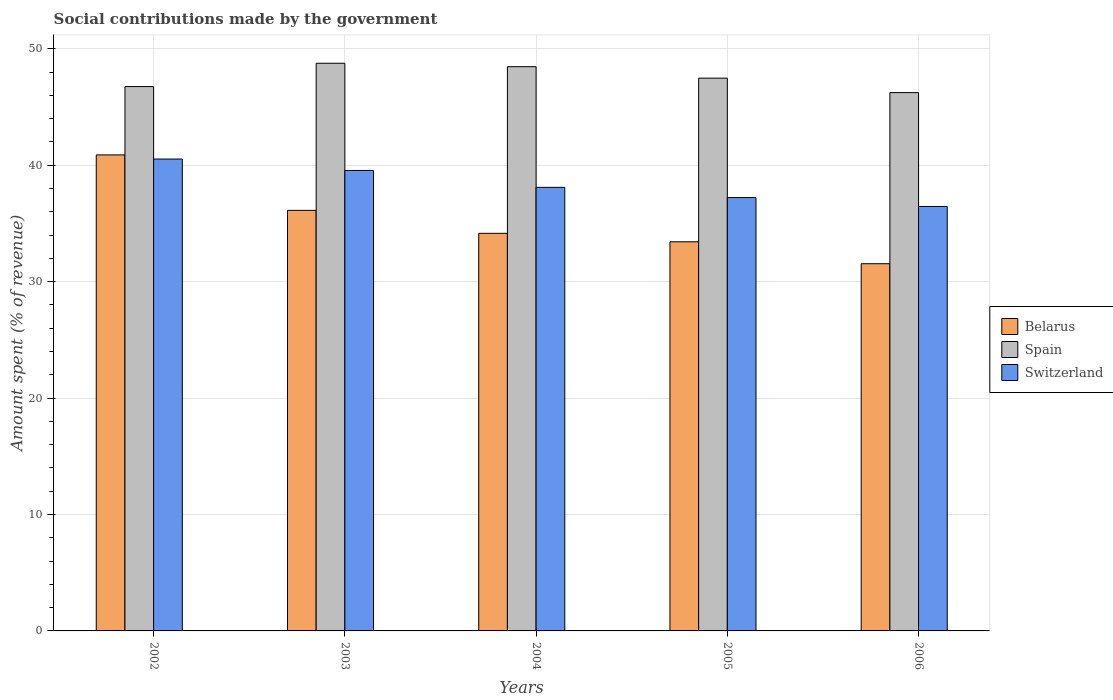Are the number of bars on each tick of the X-axis equal?
Offer a terse response. Yes. How many bars are there on the 3rd tick from the left?
Ensure brevity in your answer.  3. How many bars are there on the 5th tick from the right?
Offer a terse response. 3. In how many cases, is the number of bars for a given year not equal to the number of legend labels?
Your response must be concise. 0. What is the amount spent (in %) on social contributions in Belarus in 2006?
Provide a short and direct response. 31.54. Across all years, what is the maximum amount spent (in %) on social contributions in Switzerland?
Offer a terse response. 40.53. Across all years, what is the minimum amount spent (in %) on social contributions in Switzerland?
Your answer should be compact. 36.46. In which year was the amount spent (in %) on social contributions in Belarus maximum?
Keep it short and to the point. 2002. In which year was the amount spent (in %) on social contributions in Belarus minimum?
Keep it short and to the point. 2006. What is the total amount spent (in %) on social contributions in Belarus in the graph?
Offer a very short reply. 176.11. What is the difference between the amount spent (in %) on social contributions in Spain in 2003 and that in 2006?
Offer a terse response. 2.52. What is the difference between the amount spent (in %) on social contributions in Spain in 2006 and the amount spent (in %) on social contributions in Switzerland in 2002?
Offer a very short reply. 5.71. What is the average amount spent (in %) on social contributions in Spain per year?
Provide a succinct answer. 47.54. In the year 2003, what is the difference between the amount spent (in %) on social contributions in Belarus and amount spent (in %) on social contributions in Spain?
Your answer should be very brief. -12.63. What is the ratio of the amount spent (in %) on social contributions in Spain in 2002 to that in 2006?
Your answer should be very brief. 1.01. Is the difference between the amount spent (in %) on social contributions in Belarus in 2003 and 2004 greater than the difference between the amount spent (in %) on social contributions in Spain in 2003 and 2004?
Make the answer very short. Yes. What is the difference between the highest and the second highest amount spent (in %) on social contributions in Belarus?
Provide a succinct answer. 4.76. What is the difference between the highest and the lowest amount spent (in %) on social contributions in Belarus?
Your response must be concise. 9.34. Is the sum of the amount spent (in %) on social contributions in Switzerland in 2003 and 2006 greater than the maximum amount spent (in %) on social contributions in Spain across all years?
Your response must be concise. Yes. What does the 2nd bar from the left in 2003 represents?
Make the answer very short. Spain. Is it the case that in every year, the sum of the amount spent (in %) on social contributions in Spain and amount spent (in %) on social contributions in Belarus is greater than the amount spent (in %) on social contributions in Switzerland?
Provide a succinct answer. Yes. What is the difference between two consecutive major ticks on the Y-axis?
Your response must be concise. 10. Are the values on the major ticks of Y-axis written in scientific E-notation?
Your answer should be compact. No. Does the graph contain any zero values?
Offer a terse response. No. Does the graph contain grids?
Provide a succinct answer. Yes. Where does the legend appear in the graph?
Offer a terse response. Center right. How many legend labels are there?
Make the answer very short. 3. How are the legend labels stacked?
Offer a terse response. Vertical. What is the title of the graph?
Keep it short and to the point. Social contributions made by the government. Does "Spain" appear as one of the legend labels in the graph?
Keep it short and to the point. Yes. What is the label or title of the X-axis?
Provide a short and direct response. Years. What is the label or title of the Y-axis?
Give a very brief answer. Amount spent (% of revenue). What is the Amount spent (% of revenue) of Belarus in 2002?
Your answer should be very brief. 40.88. What is the Amount spent (% of revenue) in Spain in 2002?
Offer a terse response. 46.75. What is the Amount spent (% of revenue) in Switzerland in 2002?
Your answer should be very brief. 40.53. What is the Amount spent (% of revenue) of Belarus in 2003?
Your answer should be very brief. 36.12. What is the Amount spent (% of revenue) of Spain in 2003?
Give a very brief answer. 48.75. What is the Amount spent (% of revenue) in Switzerland in 2003?
Make the answer very short. 39.55. What is the Amount spent (% of revenue) in Belarus in 2004?
Ensure brevity in your answer.  34.15. What is the Amount spent (% of revenue) in Spain in 2004?
Ensure brevity in your answer.  48.46. What is the Amount spent (% of revenue) of Switzerland in 2004?
Give a very brief answer. 38.1. What is the Amount spent (% of revenue) in Belarus in 2005?
Offer a very short reply. 33.42. What is the Amount spent (% of revenue) of Spain in 2005?
Offer a terse response. 47.48. What is the Amount spent (% of revenue) of Switzerland in 2005?
Offer a terse response. 37.22. What is the Amount spent (% of revenue) in Belarus in 2006?
Provide a short and direct response. 31.54. What is the Amount spent (% of revenue) of Spain in 2006?
Your answer should be very brief. 46.23. What is the Amount spent (% of revenue) in Switzerland in 2006?
Provide a short and direct response. 36.46. Across all years, what is the maximum Amount spent (% of revenue) of Belarus?
Give a very brief answer. 40.88. Across all years, what is the maximum Amount spent (% of revenue) of Spain?
Offer a very short reply. 48.75. Across all years, what is the maximum Amount spent (% of revenue) in Switzerland?
Your answer should be very brief. 40.53. Across all years, what is the minimum Amount spent (% of revenue) in Belarus?
Provide a succinct answer. 31.54. Across all years, what is the minimum Amount spent (% of revenue) of Spain?
Give a very brief answer. 46.23. Across all years, what is the minimum Amount spent (% of revenue) of Switzerland?
Your answer should be compact. 36.46. What is the total Amount spent (% of revenue) of Belarus in the graph?
Keep it short and to the point. 176.11. What is the total Amount spent (% of revenue) in Spain in the graph?
Offer a terse response. 237.68. What is the total Amount spent (% of revenue) in Switzerland in the graph?
Offer a terse response. 191.85. What is the difference between the Amount spent (% of revenue) of Belarus in 2002 and that in 2003?
Offer a terse response. 4.76. What is the difference between the Amount spent (% of revenue) of Spain in 2002 and that in 2003?
Give a very brief answer. -2. What is the difference between the Amount spent (% of revenue) of Switzerland in 2002 and that in 2003?
Make the answer very short. 0.98. What is the difference between the Amount spent (% of revenue) of Belarus in 2002 and that in 2004?
Offer a terse response. 6.74. What is the difference between the Amount spent (% of revenue) in Spain in 2002 and that in 2004?
Give a very brief answer. -1.71. What is the difference between the Amount spent (% of revenue) of Switzerland in 2002 and that in 2004?
Keep it short and to the point. 2.43. What is the difference between the Amount spent (% of revenue) in Belarus in 2002 and that in 2005?
Offer a very short reply. 7.46. What is the difference between the Amount spent (% of revenue) in Spain in 2002 and that in 2005?
Offer a terse response. -0.72. What is the difference between the Amount spent (% of revenue) of Switzerland in 2002 and that in 2005?
Keep it short and to the point. 3.31. What is the difference between the Amount spent (% of revenue) of Belarus in 2002 and that in 2006?
Ensure brevity in your answer.  9.34. What is the difference between the Amount spent (% of revenue) in Spain in 2002 and that in 2006?
Give a very brief answer. 0.52. What is the difference between the Amount spent (% of revenue) of Switzerland in 2002 and that in 2006?
Offer a very short reply. 4.07. What is the difference between the Amount spent (% of revenue) of Belarus in 2003 and that in 2004?
Provide a short and direct response. 1.97. What is the difference between the Amount spent (% of revenue) in Spain in 2003 and that in 2004?
Provide a succinct answer. 0.29. What is the difference between the Amount spent (% of revenue) of Switzerland in 2003 and that in 2004?
Your answer should be compact. 1.45. What is the difference between the Amount spent (% of revenue) in Belarus in 2003 and that in 2005?
Your response must be concise. 2.7. What is the difference between the Amount spent (% of revenue) of Spain in 2003 and that in 2005?
Make the answer very short. 1.28. What is the difference between the Amount spent (% of revenue) in Switzerland in 2003 and that in 2005?
Offer a terse response. 2.33. What is the difference between the Amount spent (% of revenue) of Belarus in 2003 and that in 2006?
Provide a short and direct response. 4.58. What is the difference between the Amount spent (% of revenue) in Spain in 2003 and that in 2006?
Offer a terse response. 2.52. What is the difference between the Amount spent (% of revenue) of Switzerland in 2003 and that in 2006?
Keep it short and to the point. 3.09. What is the difference between the Amount spent (% of revenue) of Belarus in 2004 and that in 2005?
Keep it short and to the point. 0.73. What is the difference between the Amount spent (% of revenue) in Spain in 2004 and that in 2005?
Give a very brief answer. 0.99. What is the difference between the Amount spent (% of revenue) in Switzerland in 2004 and that in 2005?
Your answer should be very brief. 0.88. What is the difference between the Amount spent (% of revenue) of Belarus in 2004 and that in 2006?
Offer a very short reply. 2.61. What is the difference between the Amount spent (% of revenue) in Spain in 2004 and that in 2006?
Make the answer very short. 2.23. What is the difference between the Amount spent (% of revenue) of Switzerland in 2004 and that in 2006?
Your answer should be compact. 1.64. What is the difference between the Amount spent (% of revenue) of Belarus in 2005 and that in 2006?
Give a very brief answer. 1.88. What is the difference between the Amount spent (% of revenue) of Spain in 2005 and that in 2006?
Your answer should be very brief. 1.24. What is the difference between the Amount spent (% of revenue) of Switzerland in 2005 and that in 2006?
Offer a very short reply. 0.76. What is the difference between the Amount spent (% of revenue) in Belarus in 2002 and the Amount spent (% of revenue) in Spain in 2003?
Provide a short and direct response. -7.87. What is the difference between the Amount spent (% of revenue) of Belarus in 2002 and the Amount spent (% of revenue) of Switzerland in 2003?
Ensure brevity in your answer.  1.34. What is the difference between the Amount spent (% of revenue) in Spain in 2002 and the Amount spent (% of revenue) in Switzerland in 2003?
Make the answer very short. 7.21. What is the difference between the Amount spent (% of revenue) in Belarus in 2002 and the Amount spent (% of revenue) in Spain in 2004?
Ensure brevity in your answer.  -7.58. What is the difference between the Amount spent (% of revenue) of Belarus in 2002 and the Amount spent (% of revenue) of Switzerland in 2004?
Provide a succinct answer. 2.79. What is the difference between the Amount spent (% of revenue) of Spain in 2002 and the Amount spent (% of revenue) of Switzerland in 2004?
Keep it short and to the point. 8.66. What is the difference between the Amount spent (% of revenue) in Belarus in 2002 and the Amount spent (% of revenue) in Spain in 2005?
Offer a terse response. -6.59. What is the difference between the Amount spent (% of revenue) in Belarus in 2002 and the Amount spent (% of revenue) in Switzerland in 2005?
Give a very brief answer. 3.66. What is the difference between the Amount spent (% of revenue) in Spain in 2002 and the Amount spent (% of revenue) in Switzerland in 2005?
Ensure brevity in your answer.  9.53. What is the difference between the Amount spent (% of revenue) of Belarus in 2002 and the Amount spent (% of revenue) of Spain in 2006?
Offer a very short reply. -5.35. What is the difference between the Amount spent (% of revenue) of Belarus in 2002 and the Amount spent (% of revenue) of Switzerland in 2006?
Your answer should be compact. 4.43. What is the difference between the Amount spent (% of revenue) in Spain in 2002 and the Amount spent (% of revenue) in Switzerland in 2006?
Provide a succinct answer. 10.3. What is the difference between the Amount spent (% of revenue) of Belarus in 2003 and the Amount spent (% of revenue) of Spain in 2004?
Your answer should be compact. -12.34. What is the difference between the Amount spent (% of revenue) in Belarus in 2003 and the Amount spent (% of revenue) in Switzerland in 2004?
Your response must be concise. -1.98. What is the difference between the Amount spent (% of revenue) of Spain in 2003 and the Amount spent (% of revenue) of Switzerland in 2004?
Your answer should be very brief. 10.66. What is the difference between the Amount spent (% of revenue) of Belarus in 2003 and the Amount spent (% of revenue) of Spain in 2005?
Keep it short and to the point. -11.35. What is the difference between the Amount spent (% of revenue) in Belarus in 2003 and the Amount spent (% of revenue) in Switzerland in 2005?
Provide a short and direct response. -1.1. What is the difference between the Amount spent (% of revenue) in Spain in 2003 and the Amount spent (% of revenue) in Switzerland in 2005?
Offer a terse response. 11.54. What is the difference between the Amount spent (% of revenue) of Belarus in 2003 and the Amount spent (% of revenue) of Spain in 2006?
Ensure brevity in your answer.  -10.11. What is the difference between the Amount spent (% of revenue) in Belarus in 2003 and the Amount spent (% of revenue) in Switzerland in 2006?
Keep it short and to the point. -0.33. What is the difference between the Amount spent (% of revenue) in Spain in 2003 and the Amount spent (% of revenue) in Switzerland in 2006?
Provide a short and direct response. 12.3. What is the difference between the Amount spent (% of revenue) of Belarus in 2004 and the Amount spent (% of revenue) of Spain in 2005?
Your answer should be very brief. -13.33. What is the difference between the Amount spent (% of revenue) of Belarus in 2004 and the Amount spent (% of revenue) of Switzerland in 2005?
Provide a short and direct response. -3.07. What is the difference between the Amount spent (% of revenue) in Spain in 2004 and the Amount spent (% of revenue) in Switzerland in 2005?
Your answer should be very brief. 11.24. What is the difference between the Amount spent (% of revenue) of Belarus in 2004 and the Amount spent (% of revenue) of Spain in 2006?
Your answer should be very brief. -12.09. What is the difference between the Amount spent (% of revenue) in Belarus in 2004 and the Amount spent (% of revenue) in Switzerland in 2006?
Ensure brevity in your answer.  -2.31. What is the difference between the Amount spent (% of revenue) of Spain in 2004 and the Amount spent (% of revenue) of Switzerland in 2006?
Your answer should be very brief. 12.01. What is the difference between the Amount spent (% of revenue) in Belarus in 2005 and the Amount spent (% of revenue) in Spain in 2006?
Your answer should be compact. -12.81. What is the difference between the Amount spent (% of revenue) of Belarus in 2005 and the Amount spent (% of revenue) of Switzerland in 2006?
Offer a terse response. -3.03. What is the difference between the Amount spent (% of revenue) of Spain in 2005 and the Amount spent (% of revenue) of Switzerland in 2006?
Provide a short and direct response. 11.02. What is the average Amount spent (% of revenue) in Belarus per year?
Keep it short and to the point. 35.22. What is the average Amount spent (% of revenue) in Spain per year?
Ensure brevity in your answer.  47.54. What is the average Amount spent (% of revenue) of Switzerland per year?
Provide a short and direct response. 38.37. In the year 2002, what is the difference between the Amount spent (% of revenue) of Belarus and Amount spent (% of revenue) of Spain?
Provide a short and direct response. -5.87. In the year 2002, what is the difference between the Amount spent (% of revenue) in Belarus and Amount spent (% of revenue) in Switzerland?
Your answer should be very brief. 0.35. In the year 2002, what is the difference between the Amount spent (% of revenue) of Spain and Amount spent (% of revenue) of Switzerland?
Your answer should be very brief. 6.22. In the year 2003, what is the difference between the Amount spent (% of revenue) in Belarus and Amount spent (% of revenue) in Spain?
Provide a short and direct response. -12.63. In the year 2003, what is the difference between the Amount spent (% of revenue) in Belarus and Amount spent (% of revenue) in Switzerland?
Offer a terse response. -3.43. In the year 2003, what is the difference between the Amount spent (% of revenue) in Spain and Amount spent (% of revenue) in Switzerland?
Ensure brevity in your answer.  9.21. In the year 2004, what is the difference between the Amount spent (% of revenue) in Belarus and Amount spent (% of revenue) in Spain?
Make the answer very short. -14.31. In the year 2004, what is the difference between the Amount spent (% of revenue) of Belarus and Amount spent (% of revenue) of Switzerland?
Make the answer very short. -3.95. In the year 2004, what is the difference between the Amount spent (% of revenue) in Spain and Amount spent (% of revenue) in Switzerland?
Make the answer very short. 10.36. In the year 2005, what is the difference between the Amount spent (% of revenue) of Belarus and Amount spent (% of revenue) of Spain?
Provide a short and direct response. -14.05. In the year 2005, what is the difference between the Amount spent (% of revenue) of Belarus and Amount spent (% of revenue) of Switzerland?
Offer a very short reply. -3.8. In the year 2005, what is the difference between the Amount spent (% of revenue) in Spain and Amount spent (% of revenue) in Switzerland?
Ensure brevity in your answer.  10.26. In the year 2006, what is the difference between the Amount spent (% of revenue) of Belarus and Amount spent (% of revenue) of Spain?
Make the answer very short. -14.7. In the year 2006, what is the difference between the Amount spent (% of revenue) in Belarus and Amount spent (% of revenue) in Switzerland?
Offer a terse response. -4.92. In the year 2006, what is the difference between the Amount spent (% of revenue) in Spain and Amount spent (% of revenue) in Switzerland?
Your answer should be very brief. 9.78. What is the ratio of the Amount spent (% of revenue) of Belarus in 2002 to that in 2003?
Keep it short and to the point. 1.13. What is the ratio of the Amount spent (% of revenue) in Spain in 2002 to that in 2003?
Provide a short and direct response. 0.96. What is the ratio of the Amount spent (% of revenue) of Switzerland in 2002 to that in 2003?
Make the answer very short. 1.02. What is the ratio of the Amount spent (% of revenue) of Belarus in 2002 to that in 2004?
Provide a succinct answer. 1.2. What is the ratio of the Amount spent (% of revenue) of Spain in 2002 to that in 2004?
Offer a terse response. 0.96. What is the ratio of the Amount spent (% of revenue) in Switzerland in 2002 to that in 2004?
Provide a succinct answer. 1.06. What is the ratio of the Amount spent (% of revenue) in Belarus in 2002 to that in 2005?
Offer a terse response. 1.22. What is the ratio of the Amount spent (% of revenue) of Switzerland in 2002 to that in 2005?
Offer a terse response. 1.09. What is the ratio of the Amount spent (% of revenue) in Belarus in 2002 to that in 2006?
Ensure brevity in your answer.  1.3. What is the ratio of the Amount spent (% of revenue) in Spain in 2002 to that in 2006?
Ensure brevity in your answer.  1.01. What is the ratio of the Amount spent (% of revenue) in Switzerland in 2002 to that in 2006?
Provide a short and direct response. 1.11. What is the ratio of the Amount spent (% of revenue) in Belarus in 2003 to that in 2004?
Ensure brevity in your answer.  1.06. What is the ratio of the Amount spent (% of revenue) of Switzerland in 2003 to that in 2004?
Offer a very short reply. 1.04. What is the ratio of the Amount spent (% of revenue) of Belarus in 2003 to that in 2005?
Your response must be concise. 1.08. What is the ratio of the Amount spent (% of revenue) of Switzerland in 2003 to that in 2005?
Make the answer very short. 1.06. What is the ratio of the Amount spent (% of revenue) in Belarus in 2003 to that in 2006?
Give a very brief answer. 1.15. What is the ratio of the Amount spent (% of revenue) in Spain in 2003 to that in 2006?
Ensure brevity in your answer.  1.05. What is the ratio of the Amount spent (% of revenue) in Switzerland in 2003 to that in 2006?
Provide a succinct answer. 1.08. What is the ratio of the Amount spent (% of revenue) of Belarus in 2004 to that in 2005?
Your answer should be compact. 1.02. What is the ratio of the Amount spent (% of revenue) in Spain in 2004 to that in 2005?
Offer a very short reply. 1.02. What is the ratio of the Amount spent (% of revenue) in Switzerland in 2004 to that in 2005?
Keep it short and to the point. 1.02. What is the ratio of the Amount spent (% of revenue) of Belarus in 2004 to that in 2006?
Give a very brief answer. 1.08. What is the ratio of the Amount spent (% of revenue) of Spain in 2004 to that in 2006?
Provide a succinct answer. 1.05. What is the ratio of the Amount spent (% of revenue) of Switzerland in 2004 to that in 2006?
Keep it short and to the point. 1.04. What is the ratio of the Amount spent (% of revenue) in Belarus in 2005 to that in 2006?
Your answer should be very brief. 1.06. What is the ratio of the Amount spent (% of revenue) in Spain in 2005 to that in 2006?
Keep it short and to the point. 1.03. What is the ratio of the Amount spent (% of revenue) of Switzerland in 2005 to that in 2006?
Offer a terse response. 1.02. What is the difference between the highest and the second highest Amount spent (% of revenue) of Belarus?
Your response must be concise. 4.76. What is the difference between the highest and the second highest Amount spent (% of revenue) of Spain?
Give a very brief answer. 0.29. What is the difference between the highest and the second highest Amount spent (% of revenue) in Switzerland?
Ensure brevity in your answer.  0.98. What is the difference between the highest and the lowest Amount spent (% of revenue) in Belarus?
Ensure brevity in your answer.  9.34. What is the difference between the highest and the lowest Amount spent (% of revenue) of Spain?
Your answer should be compact. 2.52. What is the difference between the highest and the lowest Amount spent (% of revenue) of Switzerland?
Your answer should be compact. 4.07. 